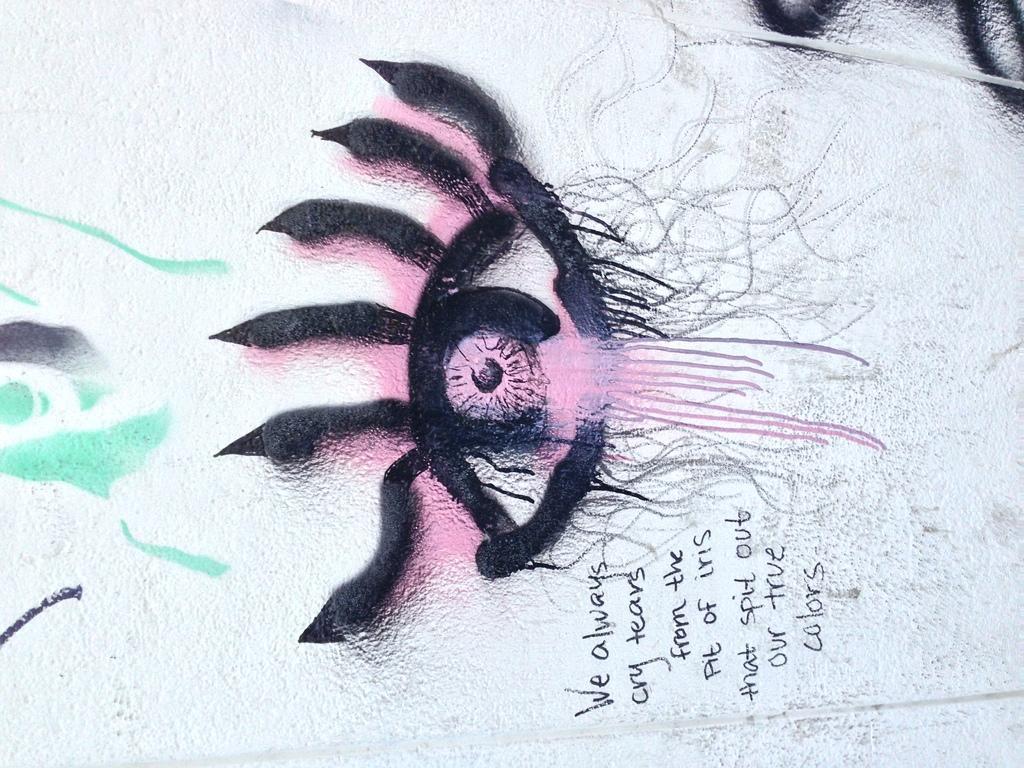Can you describe this image briefly? It looks like a painting with a white background. There is some text at the bottom. 